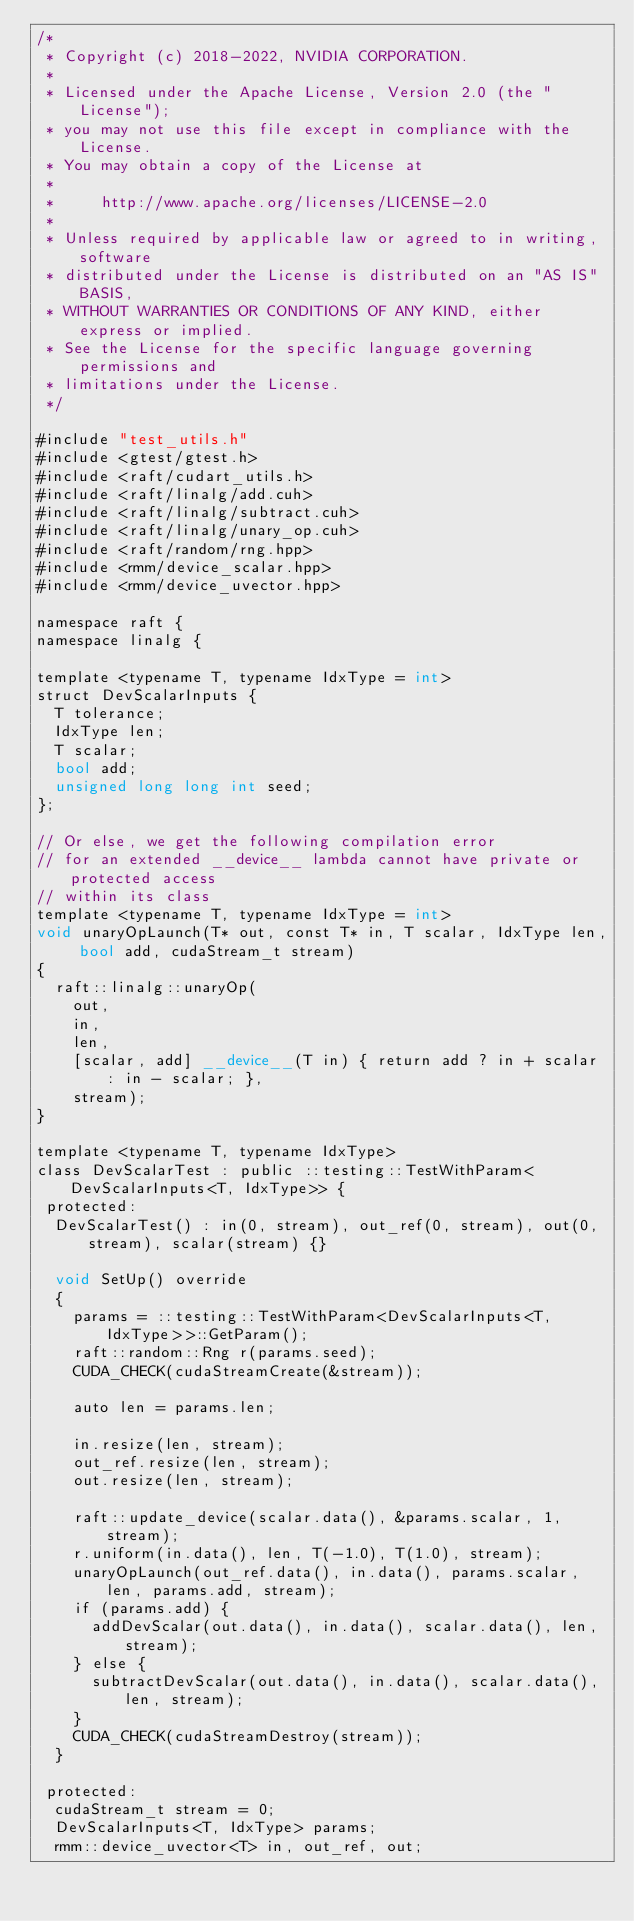<code> <loc_0><loc_0><loc_500><loc_500><_Cuda_>/*
 * Copyright (c) 2018-2022, NVIDIA CORPORATION.
 *
 * Licensed under the Apache License, Version 2.0 (the "License");
 * you may not use this file except in compliance with the License.
 * You may obtain a copy of the License at
 *
 *     http://www.apache.org/licenses/LICENSE-2.0
 *
 * Unless required by applicable law or agreed to in writing, software
 * distributed under the License is distributed on an "AS IS" BASIS,
 * WITHOUT WARRANTIES OR CONDITIONS OF ANY KIND, either express or implied.
 * See the License for the specific language governing permissions and
 * limitations under the License.
 */

#include "test_utils.h"
#include <gtest/gtest.h>
#include <raft/cudart_utils.h>
#include <raft/linalg/add.cuh>
#include <raft/linalg/subtract.cuh>
#include <raft/linalg/unary_op.cuh>
#include <raft/random/rng.hpp>
#include <rmm/device_scalar.hpp>
#include <rmm/device_uvector.hpp>

namespace raft {
namespace linalg {

template <typename T, typename IdxType = int>
struct DevScalarInputs {
  T tolerance;
  IdxType len;
  T scalar;
  bool add;
  unsigned long long int seed;
};

// Or else, we get the following compilation error
// for an extended __device__ lambda cannot have private or protected access
// within its class
template <typename T, typename IdxType = int>
void unaryOpLaunch(T* out, const T* in, T scalar, IdxType len, bool add, cudaStream_t stream)
{
  raft::linalg::unaryOp(
    out,
    in,
    len,
    [scalar, add] __device__(T in) { return add ? in + scalar : in - scalar; },
    stream);
}

template <typename T, typename IdxType>
class DevScalarTest : public ::testing::TestWithParam<DevScalarInputs<T, IdxType>> {
 protected:
  DevScalarTest() : in(0, stream), out_ref(0, stream), out(0, stream), scalar(stream) {}

  void SetUp() override
  {
    params = ::testing::TestWithParam<DevScalarInputs<T, IdxType>>::GetParam();
    raft::random::Rng r(params.seed);
    CUDA_CHECK(cudaStreamCreate(&stream));

    auto len = params.len;

    in.resize(len, stream);
    out_ref.resize(len, stream);
    out.resize(len, stream);

    raft::update_device(scalar.data(), &params.scalar, 1, stream);
    r.uniform(in.data(), len, T(-1.0), T(1.0), stream);
    unaryOpLaunch(out_ref.data(), in.data(), params.scalar, len, params.add, stream);
    if (params.add) {
      addDevScalar(out.data(), in.data(), scalar.data(), len, stream);
    } else {
      subtractDevScalar(out.data(), in.data(), scalar.data(), len, stream);
    }
    CUDA_CHECK(cudaStreamDestroy(stream));
  }

 protected:
  cudaStream_t stream = 0;
  DevScalarInputs<T, IdxType> params;
  rmm::device_uvector<T> in, out_ref, out;</code> 